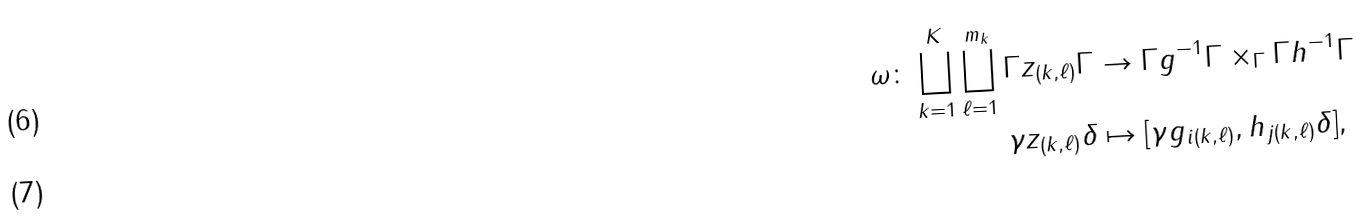Convert formula to latex. <formula><loc_0><loc_0><loc_500><loc_500>\omega \colon \bigsqcup _ { k = 1 } ^ { K } \bigsqcup _ { \ell = 1 } ^ { m _ { k } } \Gamma z _ { ( k , \ell ) } \Gamma & \to \Gamma g ^ { - 1 } \Gamma \times _ { \Gamma } \Gamma h ^ { - 1 } \Gamma \\ \gamma z _ { ( k , \ell ) } \delta & \mapsto [ \gamma g _ { i ( k , \ell ) } , h _ { j ( k , \ell ) } \delta ] ,</formula> 